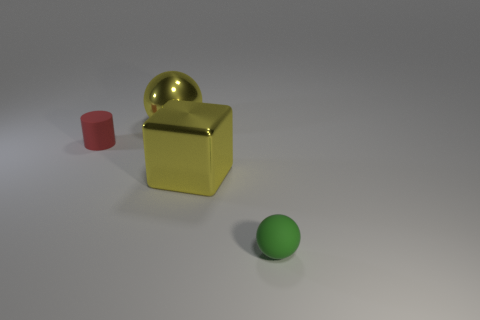Add 4 small blue matte cylinders. How many objects exist? 8 Subtract all cylinders. How many objects are left? 3 Subtract 1 spheres. How many spheres are left? 1 Subtract 1 yellow spheres. How many objects are left? 3 Subtract all yellow balls. Subtract all gray cylinders. How many balls are left? 1 Subtract all rubber things. Subtract all tiny red matte cylinders. How many objects are left? 1 Add 3 large yellow blocks. How many large yellow blocks are left? 4 Add 3 brown metal objects. How many brown metal objects exist? 3 